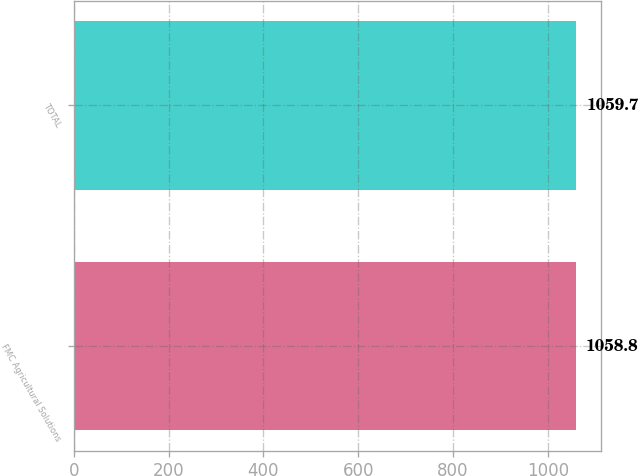<chart> <loc_0><loc_0><loc_500><loc_500><bar_chart><fcel>FMC Agricultural Solutions<fcel>TOTAL<nl><fcel>1058.8<fcel>1059.7<nl></chart> 